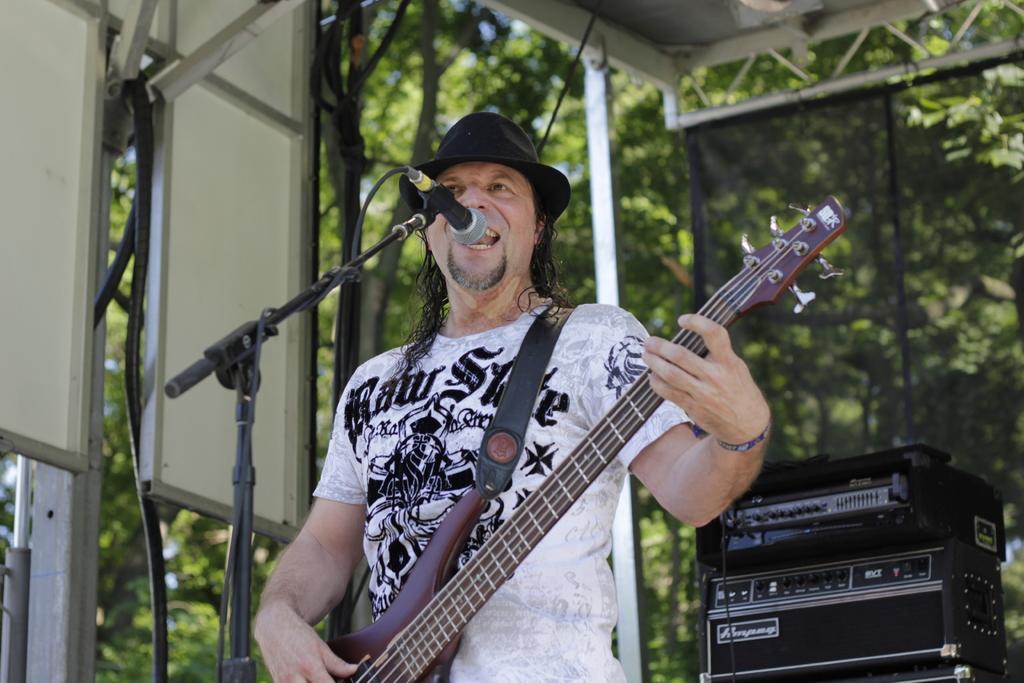Please provide a concise description of this image. In this image the man is standing and holding a guitar. There is mic and stand. At the back side there are trees. 